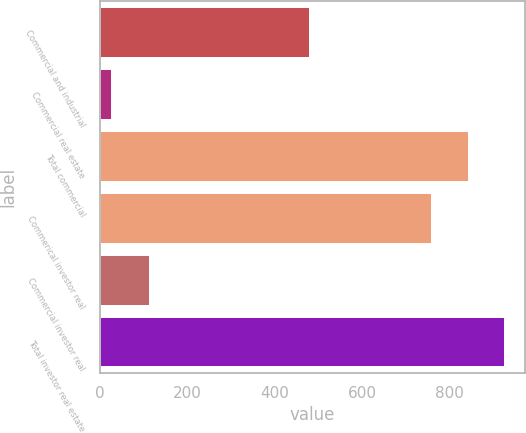Convert chart to OTSL. <chart><loc_0><loc_0><loc_500><loc_500><bar_chart><fcel>Commercial and industrial<fcel>Commercial real estate<fcel>Total commercial<fcel>Commerical investor real<fcel>Commercial investor real<fcel>Total investor real estate<nl><fcel>479<fcel>27<fcel>840.2<fcel>756<fcel>113<fcel>924.4<nl></chart> 